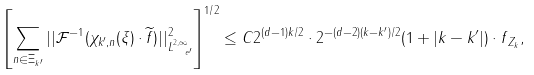Convert formula to latex. <formula><loc_0><loc_0><loc_500><loc_500>\left [ \sum _ { n \in \Xi _ { k ^ { \prime } } } | | \mathcal { F } ^ { - 1 } ( \chi _ { k ^ { \prime } , n } ( \xi ) \cdot \widetilde { f } ) | | _ { L ^ { 2 , \infty } _ { \ e ^ { \prime } } } ^ { 2 } \right ] ^ { 1 / 2 } \leq C 2 ^ { ( d - 1 ) k / 2 } \cdot 2 ^ { - ( d - 2 ) ( k - k ^ { \prime } ) / 2 } ( 1 + | k - k ^ { \prime } | ) \cdot \| f \| _ { Z _ { k } } ,</formula> 